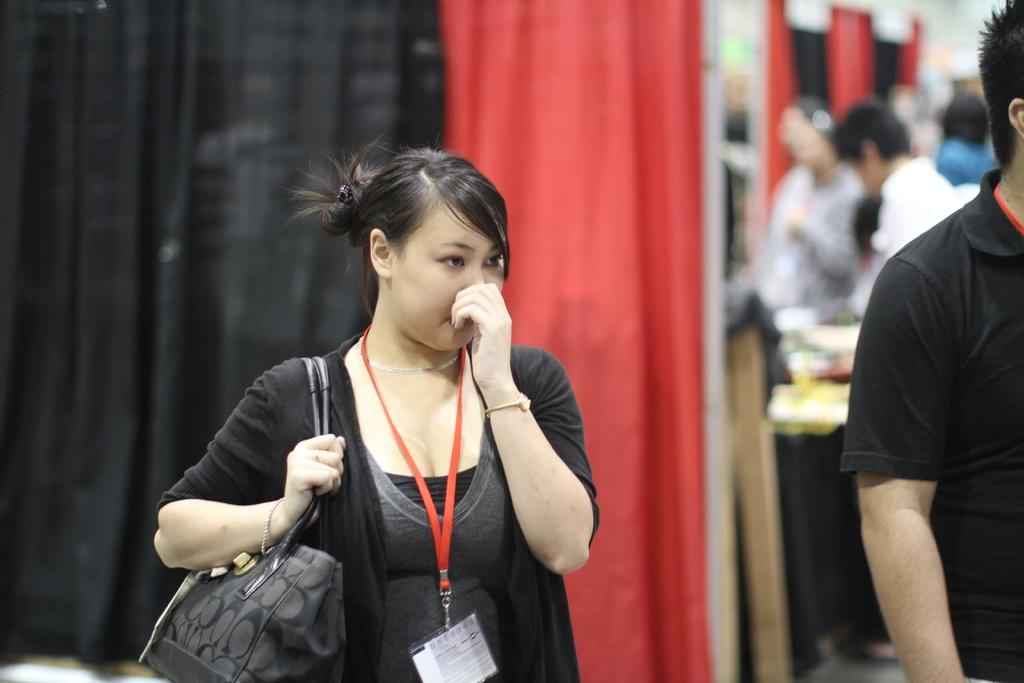What color is the jacket the woman is wearing in the image? The woman is wearing a black jacket. What is the woman holding in the image? The woman is holding a handbag. What color is the t-shirt the man is wearing in the image? The man is wearing a black t-shirt. What type of curtain can be seen in the image? There is a red and black curtain in the image. What are the woman and man doing in the image? The woman and man are standing. What type of straw is the woman using to express her anger in the image? There is no straw or indication of anger present in the image. What type of lace is visible on the man's clothing in the image? There is no lace visible on the man's clothing in the image; he is wearing a black t-shirt. 